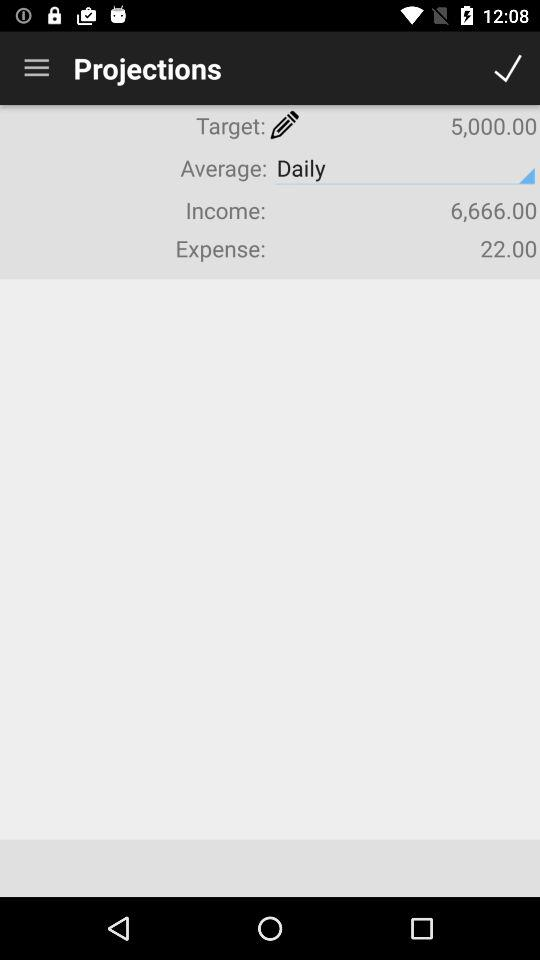What is the average schedule? The average schedule is "Daily". 